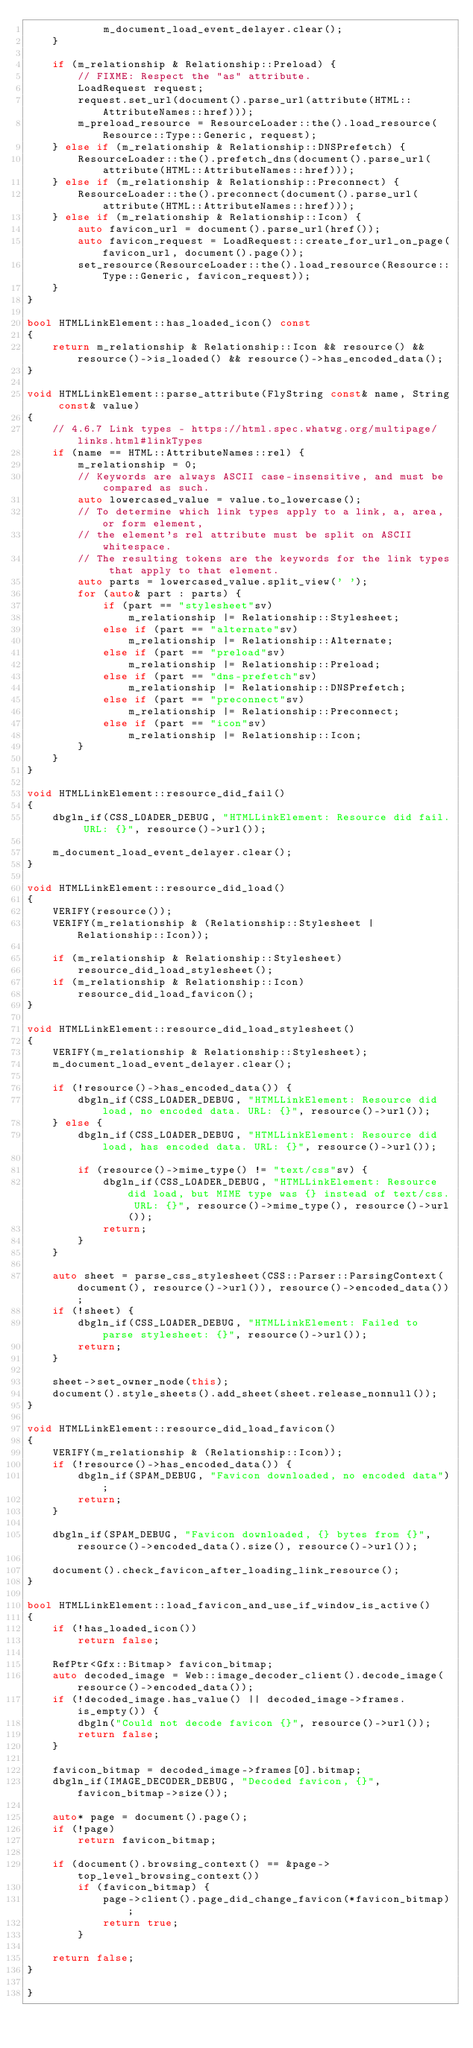Convert code to text. <code><loc_0><loc_0><loc_500><loc_500><_C++_>            m_document_load_event_delayer.clear();
    }

    if (m_relationship & Relationship::Preload) {
        // FIXME: Respect the "as" attribute.
        LoadRequest request;
        request.set_url(document().parse_url(attribute(HTML::AttributeNames::href)));
        m_preload_resource = ResourceLoader::the().load_resource(Resource::Type::Generic, request);
    } else if (m_relationship & Relationship::DNSPrefetch) {
        ResourceLoader::the().prefetch_dns(document().parse_url(attribute(HTML::AttributeNames::href)));
    } else if (m_relationship & Relationship::Preconnect) {
        ResourceLoader::the().preconnect(document().parse_url(attribute(HTML::AttributeNames::href)));
    } else if (m_relationship & Relationship::Icon) {
        auto favicon_url = document().parse_url(href());
        auto favicon_request = LoadRequest::create_for_url_on_page(favicon_url, document().page());
        set_resource(ResourceLoader::the().load_resource(Resource::Type::Generic, favicon_request));
    }
}

bool HTMLLinkElement::has_loaded_icon() const
{
    return m_relationship & Relationship::Icon && resource() && resource()->is_loaded() && resource()->has_encoded_data();
}

void HTMLLinkElement::parse_attribute(FlyString const& name, String const& value)
{
    // 4.6.7 Link types - https://html.spec.whatwg.org/multipage/links.html#linkTypes
    if (name == HTML::AttributeNames::rel) {
        m_relationship = 0;
        // Keywords are always ASCII case-insensitive, and must be compared as such.
        auto lowercased_value = value.to_lowercase();
        // To determine which link types apply to a link, a, area, or form element,
        // the element's rel attribute must be split on ASCII whitespace.
        // The resulting tokens are the keywords for the link types that apply to that element.
        auto parts = lowercased_value.split_view(' ');
        for (auto& part : parts) {
            if (part == "stylesheet"sv)
                m_relationship |= Relationship::Stylesheet;
            else if (part == "alternate"sv)
                m_relationship |= Relationship::Alternate;
            else if (part == "preload"sv)
                m_relationship |= Relationship::Preload;
            else if (part == "dns-prefetch"sv)
                m_relationship |= Relationship::DNSPrefetch;
            else if (part == "preconnect"sv)
                m_relationship |= Relationship::Preconnect;
            else if (part == "icon"sv)
                m_relationship |= Relationship::Icon;
        }
    }
}

void HTMLLinkElement::resource_did_fail()
{
    dbgln_if(CSS_LOADER_DEBUG, "HTMLLinkElement: Resource did fail. URL: {}", resource()->url());

    m_document_load_event_delayer.clear();
}

void HTMLLinkElement::resource_did_load()
{
    VERIFY(resource());
    VERIFY(m_relationship & (Relationship::Stylesheet | Relationship::Icon));

    if (m_relationship & Relationship::Stylesheet)
        resource_did_load_stylesheet();
    if (m_relationship & Relationship::Icon)
        resource_did_load_favicon();
}

void HTMLLinkElement::resource_did_load_stylesheet()
{
    VERIFY(m_relationship & Relationship::Stylesheet);
    m_document_load_event_delayer.clear();

    if (!resource()->has_encoded_data()) {
        dbgln_if(CSS_LOADER_DEBUG, "HTMLLinkElement: Resource did load, no encoded data. URL: {}", resource()->url());
    } else {
        dbgln_if(CSS_LOADER_DEBUG, "HTMLLinkElement: Resource did load, has encoded data. URL: {}", resource()->url());

        if (resource()->mime_type() != "text/css"sv) {
            dbgln_if(CSS_LOADER_DEBUG, "HTMLLinkElement: Resource did load, but MIME type was {} instead of text/css. URL: {}", resource()->mime_type(), resource()->url());
            return;
        }
    }

    auto sheet = parse_css_stylesheet(CSS::Parser::ParsingContext(document(), resource()->url()), resource()->encoded_data());
    if (!sheet) {
        dbgln_if(CSS_LOADER_DEBUG, "HTMLLinkElement: Failed to parse stylesheet: {}", resource()->url());
        return;
    }

    sheet->set_owner_node(this);
    document().style_sheets().add_sheet(sheet.release_nonnull());
}

void HTMLLinkElement::resource_did_load_favicon()
{
    VERIFY(m_relationship & (Relationship::Icon));
    if (!resource()->has_encoded_data()) {
        dbgln_if(SPAM_DEBUG, "Favicon downloaded, no encoded data");
        return;
    }

    dbgln_if(SPAM_DEBUG, "Favicon downloaded, {} bytes from {}", resource()->encoded_data().size(), resource()->url());

    document().check_favicon_after_loading_link_resource();
}

bool HTMLLinkElement::load_favicon_and_use_if_window_is_active()
{
    if (!has_loaded_icon())
        return false;

    RefPtr<Gfx::Bitmap> favicon_bitmap;
    auto decoded_image = Web::image_decoder_client().decode_image(resource()->encoded_data());
    if (!decoded_image.has_value() || decoded_image->frames.is_empty()) {
        dbgln("Could not decode favicon {}", resource()->url());
        return false;
    }

    favicon_bitmap = decoded_image->frames[0].bitmap;
    dbgln_if(IMAGE_DECODER_DEBUG, "Decoded favicon, {}", favicon_bitmap->size());

    auto* page = document().page();
    if (!page)
        return favicon_bitmap;

    if (document().browsing_context() == &page->top_level_browsing_context())
        if (favicon_bitmap) {
            page->client().page_did_change_favicon(*favicon_bitmap);
            return true;
        }

    return false;
}

}
</code> 